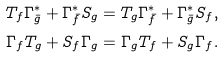<formula> <loc_0><loc_0><loc_500><loc_500>T _ { f } { \Gamma ^ { * } _ { \bar { g } } } + { \Gamma ^ { * } _ { \bar { f } } } { S _ { g } } & = T _ { g } { \Gamma ^ { * } _ { \bar { f } } } + { \Gamma ^ { * } _ { \bar { g } } } { S _ { f } } , \\ \Gamma _ { f } T _ { g } + S _ { f } { \Gamma _ { g } } & = \Gamma _ { g } T _ { f } + S _ { g } { \Gamma _ { f } } .</formula> 